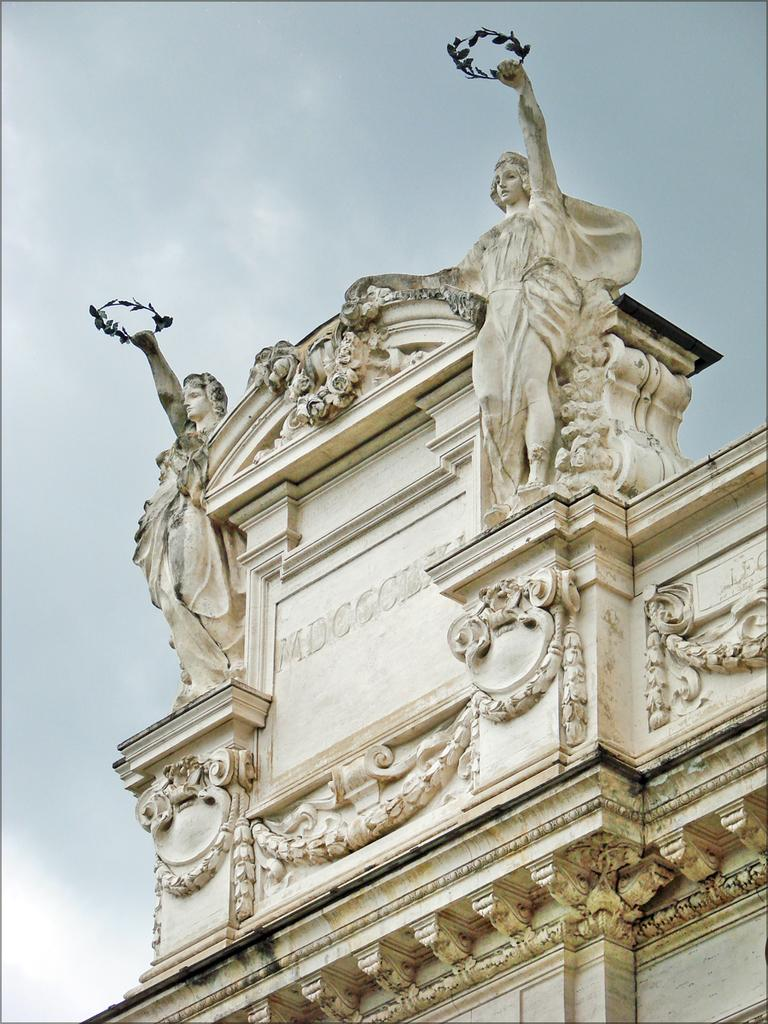What is the main structure in the image? There is a building in the image. What decorative elements are present on the building? The building has statues on it. What can be seen in the background of the image? The sky is visible in the background of the image. How many matches are being used to light the sponge in the image? There are no matches or sponge present in the image. 